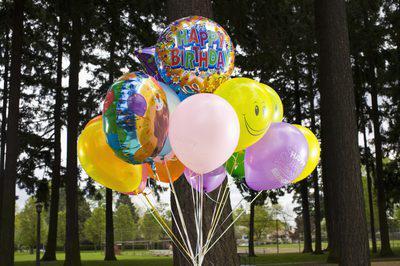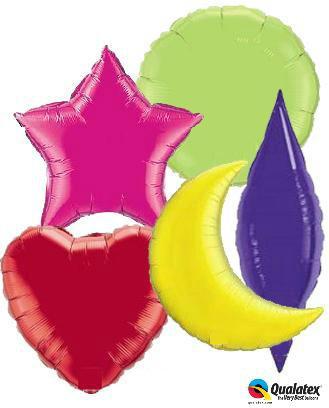The first image is the image on the left, the second image is the image on the right. Considering the images on both sides, is "One person whose face cannot be seen is holding at least one balloon." valid? Answer yes or no. No. 